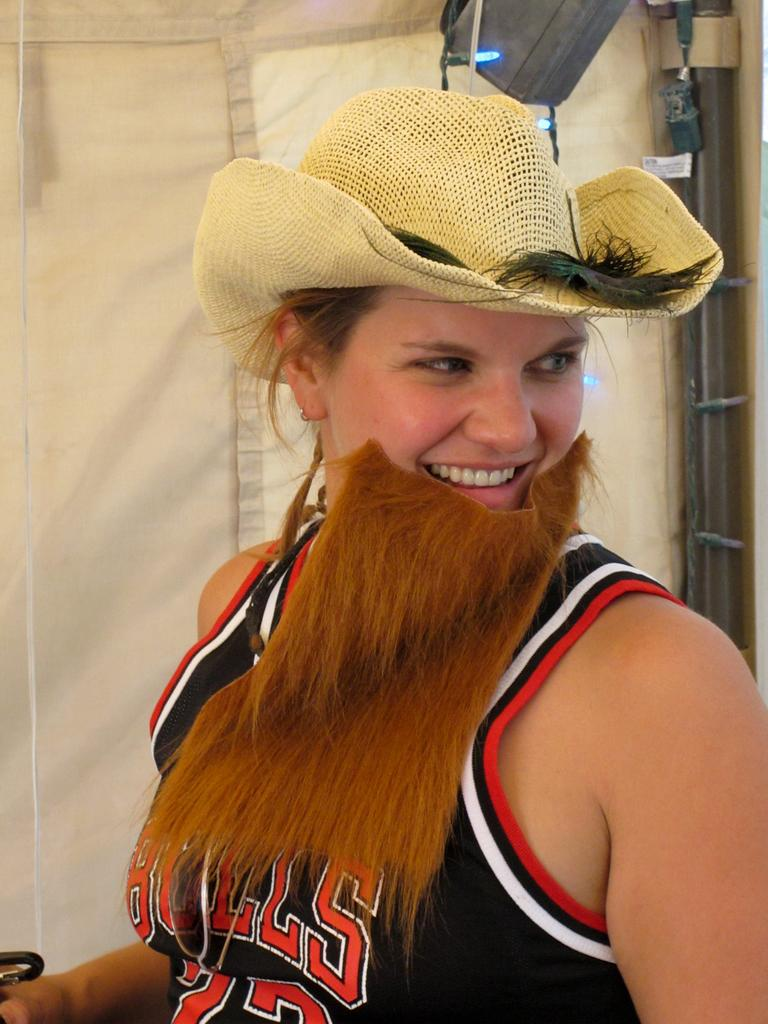<image>
Share a concise interpretation of the image provided. Girl wearing a fake beard and a Bulls jersey. 